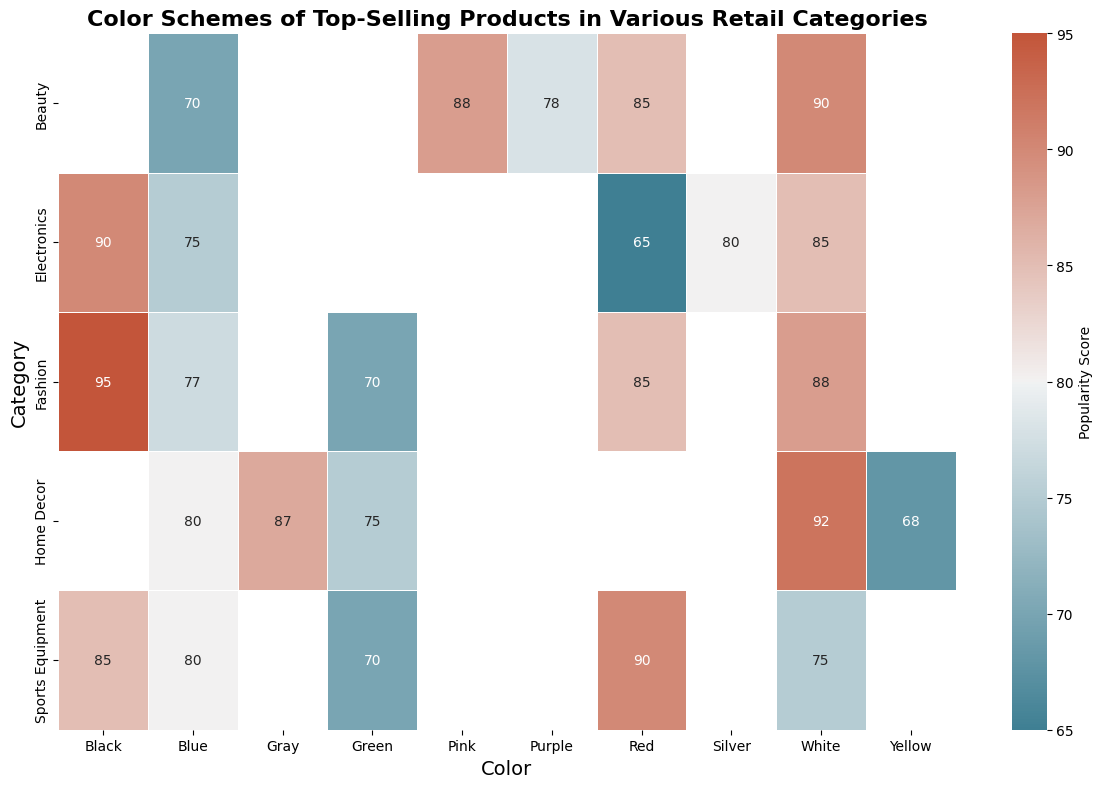What is the most popular color in the Electronics category? The heatmap shows the popularity scores for different colors in the Electronics category. The color with the highest popularity score in the Electronics category is Black with a score of 90.
Answer: Black Which category has the highest popularity score for the color White? By examining the heatmap, we see that the Home Decor category has the highest popularity score for White with a score of 92.
Answer: Home Decor Compare the popularity scores of Red and Blue in the Fashion category. Which is higher? The heatmap indicates that in the Fashion category, the popularity score for Red is 85, and for Blue it is 77. The score for Red is higher.
Answer: Red What is the sum of the popularity scores for Blue across all categories? Summing up the popularity scores for Blue across all categories: Electronics (75) + Fashion (77) + Home Decor (80) + Sports Equipment (80) + Beauty (70) = 382.
Answer: 382 What is the average popularity score for the Black color across all categories? Summing the popularity scores for Black across all categories: Electronics (90) + Fashion (95) + Sports Equipment (85) = 270. The average score is 270 / 3 = 90.
Answer: 90 Identify the least popular color in the Home Decor category. In the Home Decor category, the least popular color based on the heatmap is Yellow with a score of 68.
Answer: Yellow Is the popularity score of Purple in Beauty greater than the popularity score of Green in Sports Equipment? The heatmap shows that the popularity score for Purple in the Beauty category is 78, while the score for Green in Sports Equipment is 70. Since 78 is greater than 70, the answer is yes.
Answer: Yes How does the popularity of Red in the Sports Equipment category compare to Red in the Beauty category? The heatmap shows that the popularity score for Red in the Sports Equipment category is 90 while in the Beauty category it is 85. The score for Red in Sports Equipment is higher.
Answer: Sports Equipment Which category has higher popularity for Green: Fashion or Home Decor? The heatmap shows that the popularity score for Green in Fashion is 70 and in Home Decor it is 75. Therefore, Home Decor has a higher popularity score for Green.
Answer: Home Decor 